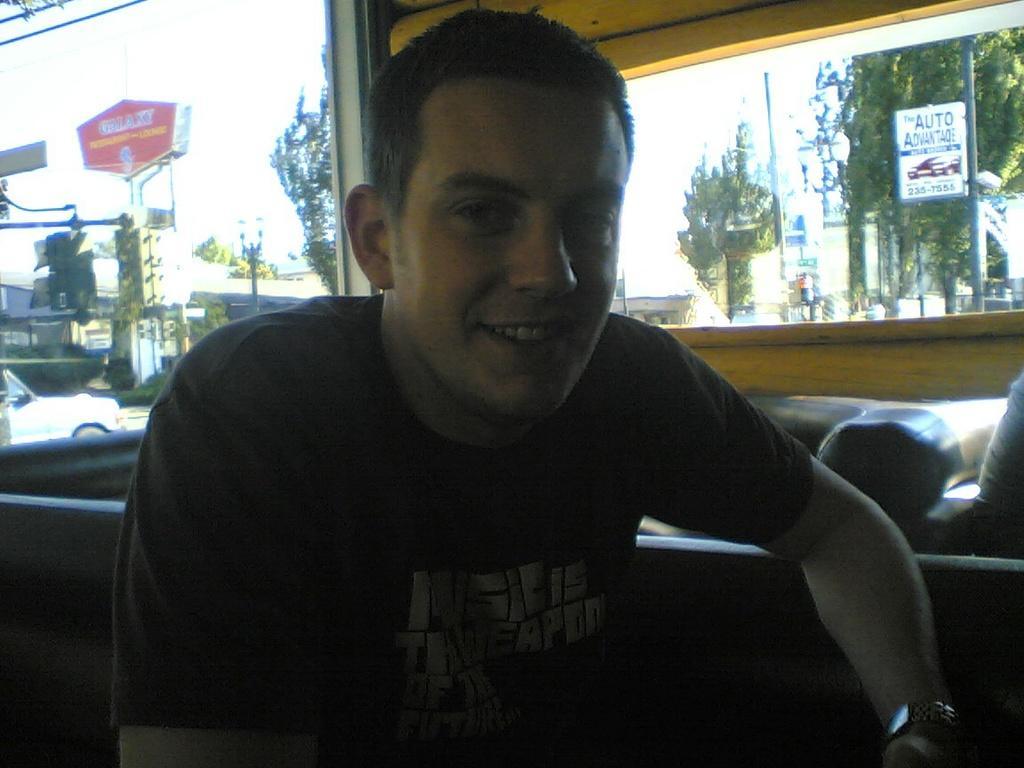Can you describe this image briefly? Here we can see a man and he is smiling. In the background we can see trees, poles, boards, vehicles, and sky. 